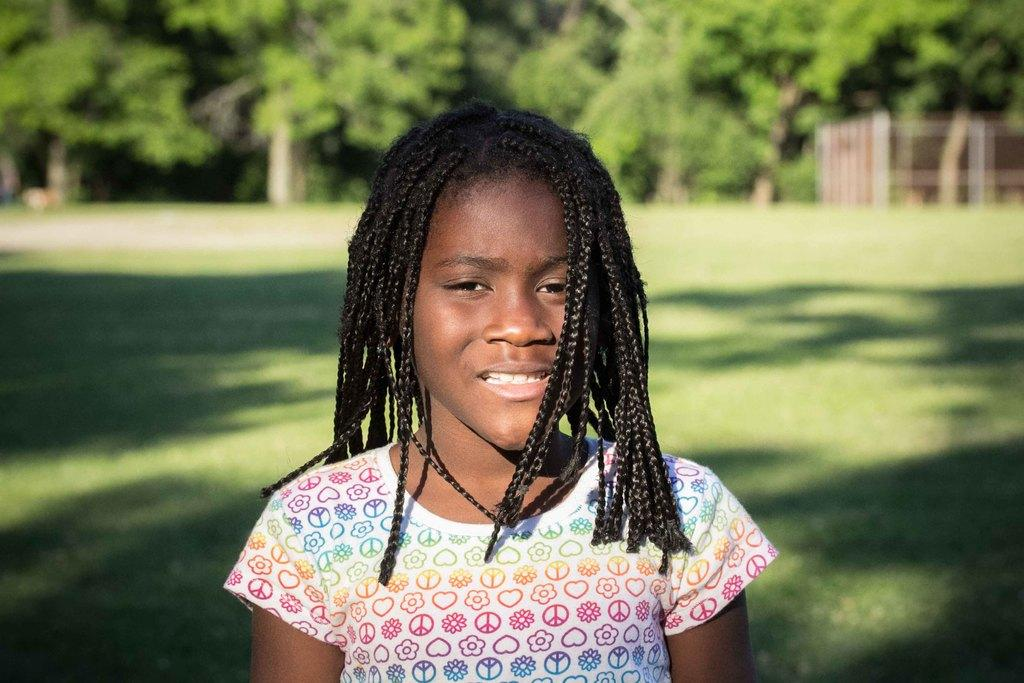Who is the main subject in the image? There is a girl in the image. What is the girl's location in the image? The girl is standing on a grass field. What can be seen in the background of the image? There is a group of trees and poles in the background of the image. What time of day is it in the image, and what does the girl's parent think about her standing on the grass field? The provided facts do not mention the time of day or the girl's parent, so we cannot answer these questions based on the information given. 